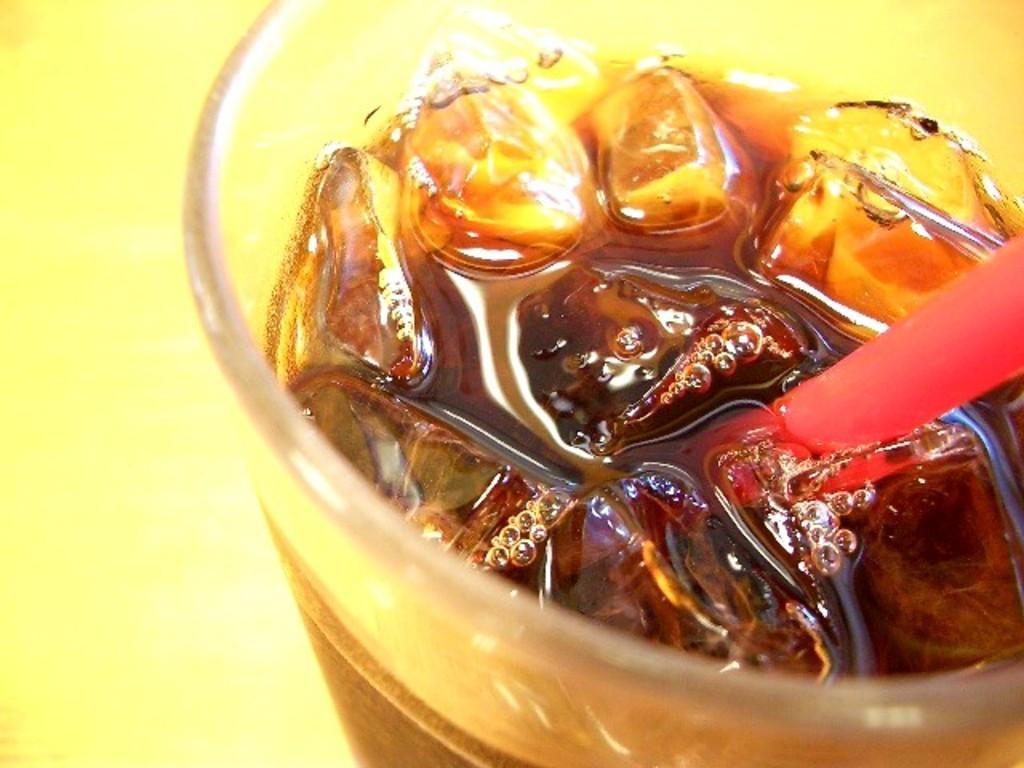What is in the glass that is visible in the image? There is a drink in the glass in the image. How might someone consume the drink in the glass? There is a straw in the glass, which can be used for drinking. What color is the surface beneath the glass? The surface beneath the glass is yellow. Where is the map located in the image? There is no map present in the image. What type of egg is visible in the image? There are no eggs present in the image. 